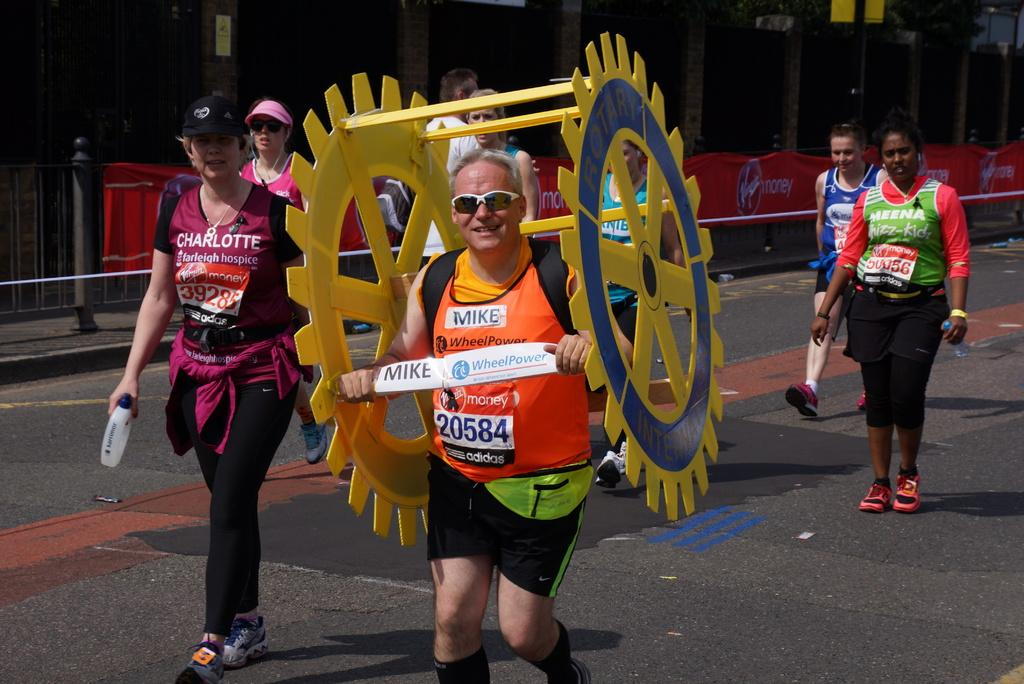How many people are in the image? There is a group of people in the image. What are the people in the image doing? The people are walking on a road. Can you describe any specific object one person is holding? One person in the group is holding a wheel. What can be seen beside the road in the image? There is a building beside the road. What is in front of the building? There is a fence in front of the building. What type of appliance can be seen in the image? There is no appliance present in the image. How many screws are visible on the home in the image? There is no home present in the image, so it's not possible to determine the number of screws. 